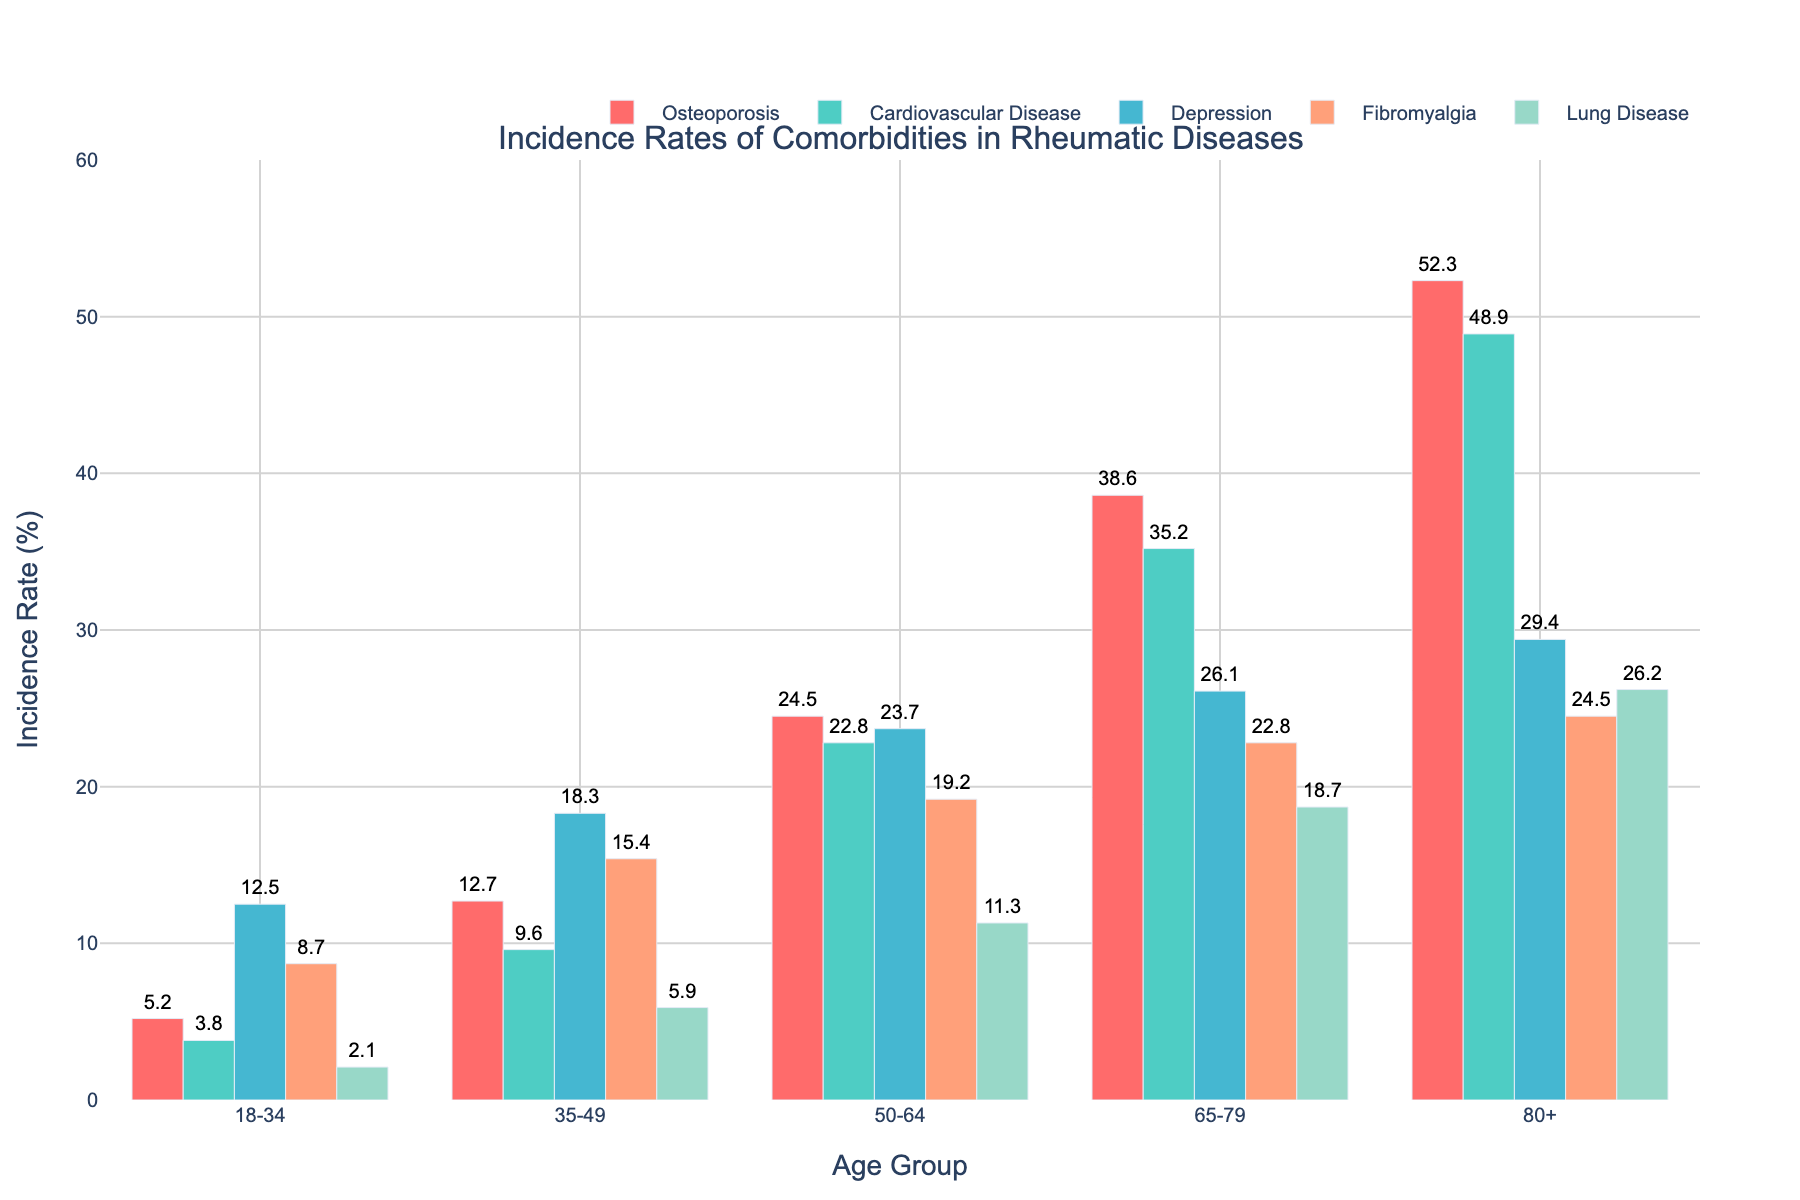Which age group has the highest incidence rate of cardiovascular disease? Cardiovascular disease bars are represented in green. The tallest green bar is associated with the "80+" age group.
Answer: 80+ Among the listed comorbidities, which has the lowest incidence rate in the 50-64 age group? For the 50-64 age group, the incidence rates for the conditions are: Osteoporosis (24.5), Cardiovascular Disease (22.8), Depression (23.7), Fibromyalgia (19.2), and Lung Disease (11.3). The lowest value is 11.3 for Lung Disease.
Answer: Lung Disease Compare the incidence rates of depression between the 35-49 age group and the 65-79 age group. Which is higher and by how much? The incidence rates for depression are 18.3 for the 35-49 age group and 26.1 for the 65-79 age group. 26.1 is higher than 18.3. The difference is 26.1 - 18.3 = 7.8.
Answer: 65-79 is higher by 7.8 What is the average incidence rate of osteoporosis across all age groups? The incidence rates of osteoporosis across the age groups are: 5.2, 12.7, 24.5, 38.6, 52.3. Sum these values: 5.2 + 12.7 + 24.5 + 38.6 + 52.3 = 133.3. The average is 133.3 / 5 = 26.66.
Answer: 26.66 Between fibromyalgia and lung disease, which comorbidity shows a sharper increase in incidence from the 18-34 age group to the 50-64 age group? Incidence rates for fibromyalgia increase from 8.7 to 19.2 (difference of 19.2 - 8.7 = 10.5). For lung disease, the rates increase from 2.1 to 11.3 (difference of 11.3 - 2.1 = 9.2). Fibromyalgia shows a sharper increase (10.5 vs. 9.2).
Answer: Fibromyalgia Which comorbidity shows the least variation in incidence rates across all age groups? To determine the least variation, identify the range (maximum minus minimum) for each comorbidity. The variations are: 
- Osteoporosis: 52.3 - 5.2 = 47.1
- Cardiovascular Disease: 48.9 - 3.8 = 45.1
- Depression: 29.4 - 12.5 = 16.9
- Fibromyalgia: 24.5 - 8.7 = 15.8
- Lung Disease: 26.2 - 2.1 = 24.1 
Fibromyalgia has the smallest range (15.8).
Answer: Fibromyalgia 